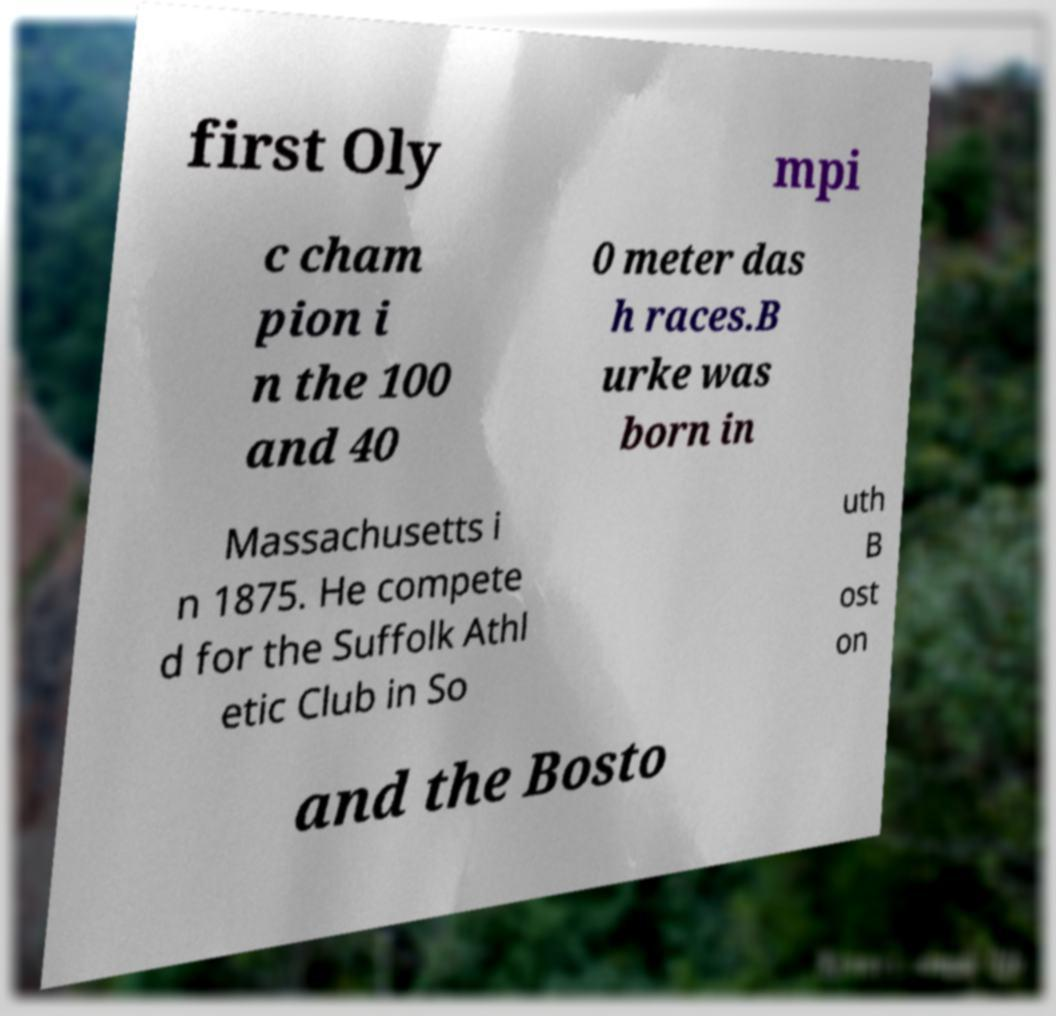Please read and relay the text visible in this image. What does it say? first Oly mpi c cham pion i n the 100 and 40 0 meter das h races.B urke was born in Massachusetts i n 1875. He compete d for the Suffolk Athl etic Club in So uth B ost on and the Bosto 